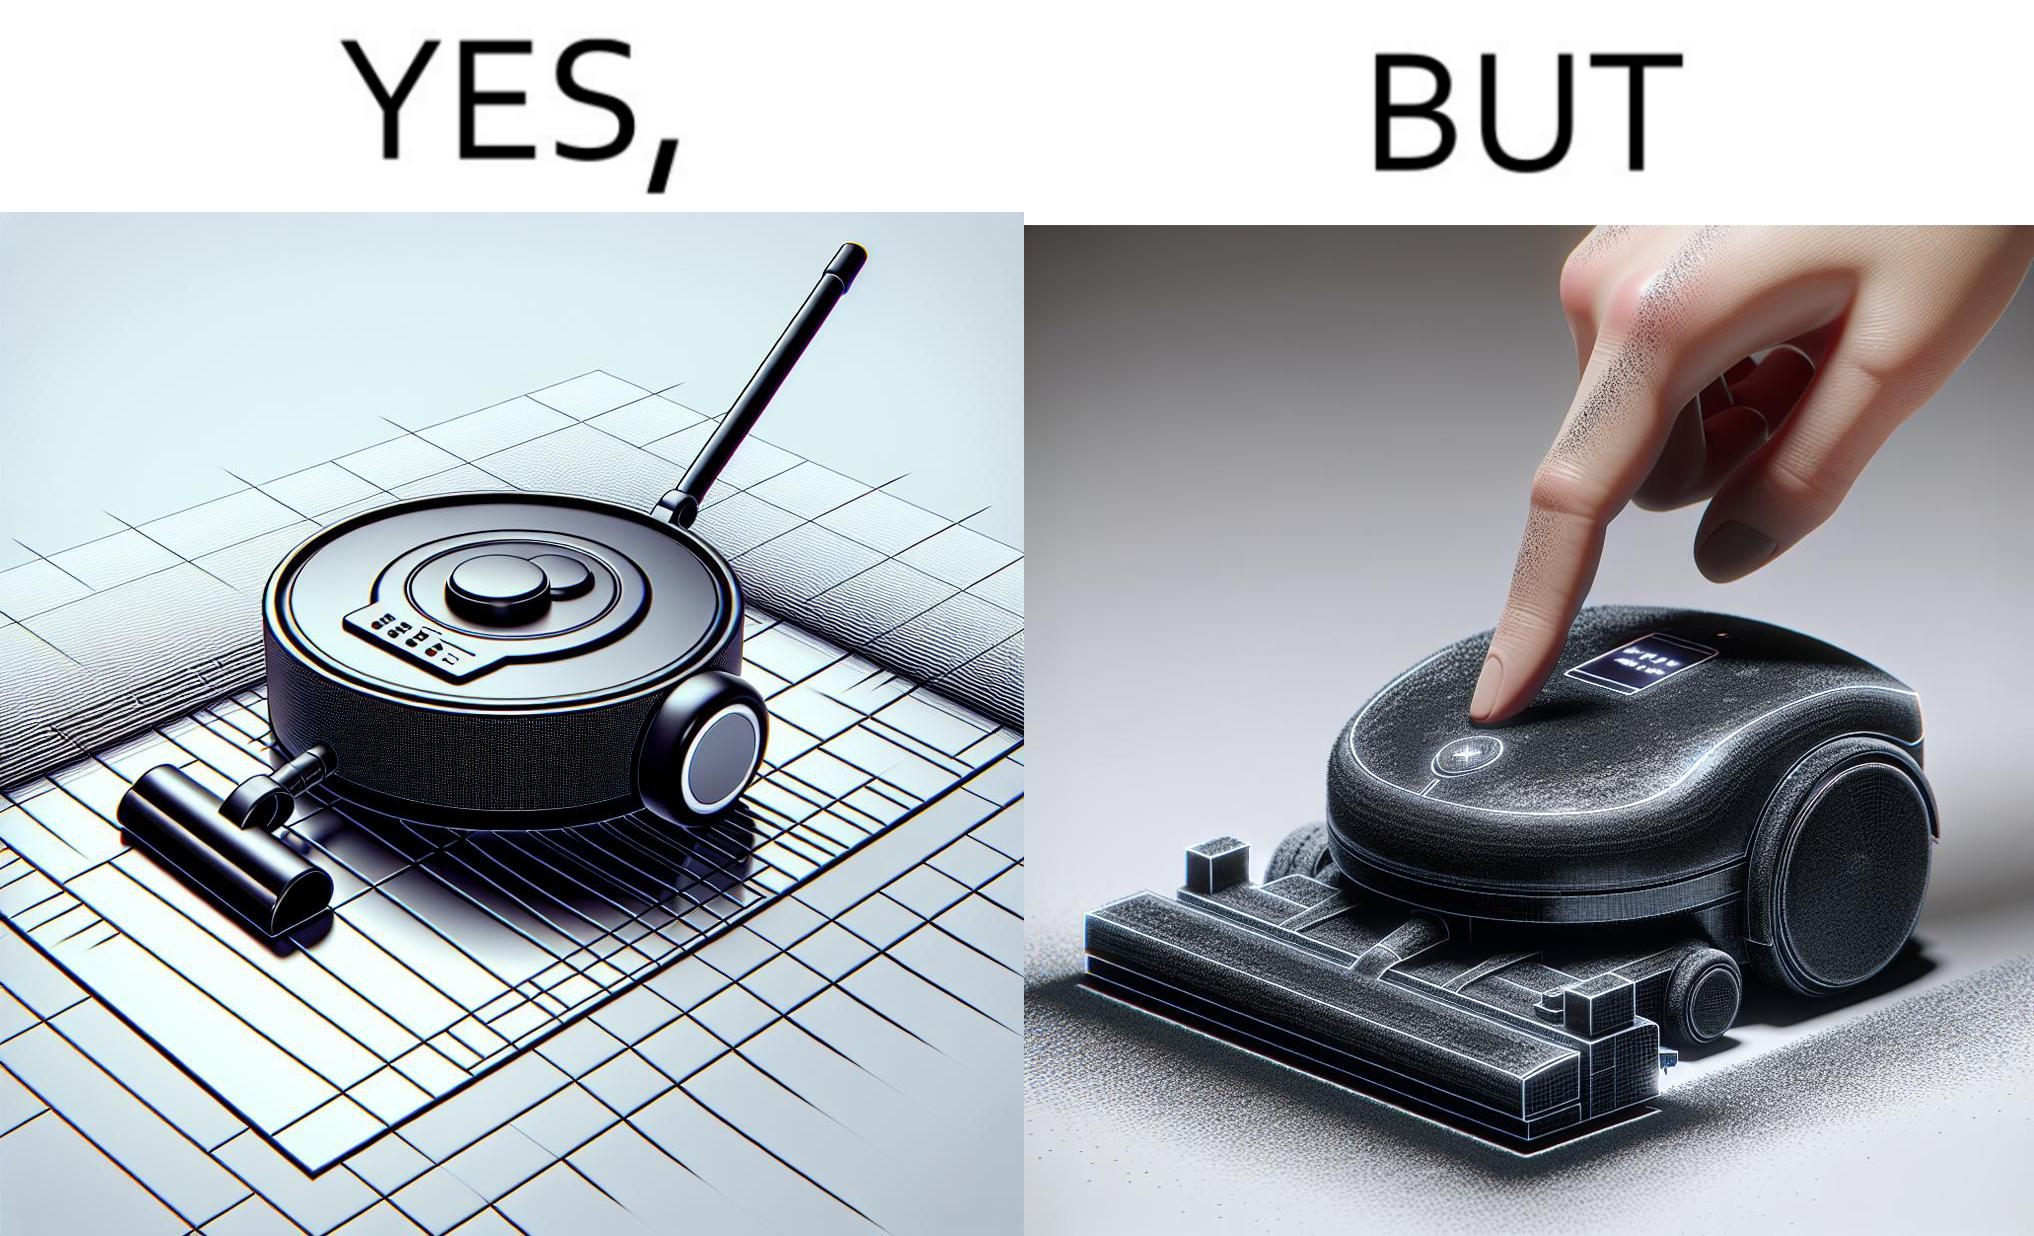Would you classify this image as satirical? Yes, this image is satirical. 